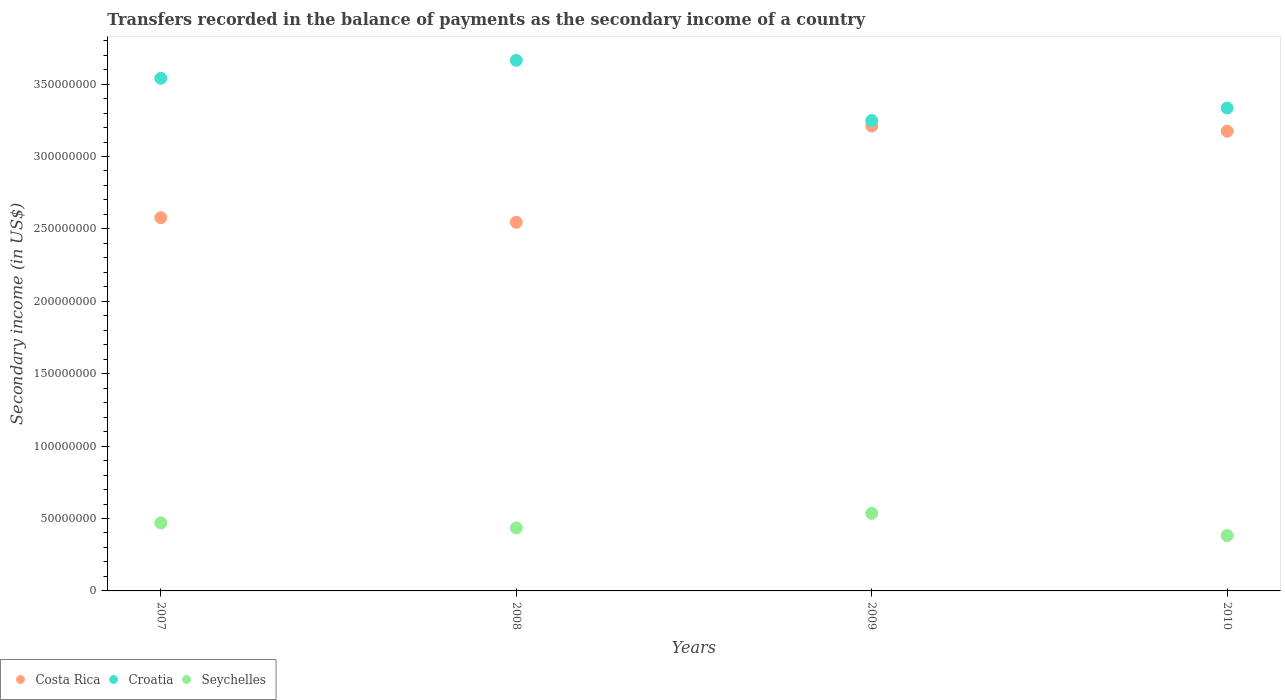Is the number of dotlines equal to the number of legend labels?
Give a very brief answer. Yes. What is the secondary income of in Croatia in 2007?
Your answer should be very brief. 3.54e+08. Across all years, what is the maximum secondary income of in Croatia?
Keep it short and to the point. 3.66e+08. Across all years, what is the minimum secondary income of in Croatia?
Your answer should be very brief. 3.25e+08. What is the total secondary income of in Croatia in the graph?
Keep it short and to the point. 1.38e+09. What is the difference between the secondary income of in Costa Rica in 2007 and that in 2009?
Keep it short and to the point. -6.33e+07. What is the difference between the secondary income of in Costa Rica in 2010 and the secondary income of in Seychelles in 2007?
Offer a very short reply. 2.71e+08. What is the average secondary income of in Seychelles per year?
Give a very brief answer. 4.55e+07. In the year 2008, what is the difference between the secondary income of in Costa Rica and secondary income of in Croatia?
Keep it short and to the point. -1.12e+08. In how many years, is the secondary income of in Seychelles greater than 10000000 US$?
Make the answer very short. 4. What is the ratio of the secondary income of in Costa Rica in 2007 to that in 2009?
Offer a very short reply. 0.8. What is the difference between the highest and the second highest secondary income of in Seychelles?
Provide a short and direct response. 6.59e+06. What is the difference between the highest and the lowest secondary income of in Croatia?
Give a very brief answer. 4.16e+07. In how many years, is the secondary income of in Seychelles greater than the average secondary income of in Seychelles taken over all years?
Provide a short and direct response. 2. Is it the case that in every year, the sum of the secondary income of in Seychelles and secondary income of in Croatia  is greater than the secondary income of in Costa Rica?
Provide a short and direct response. Yes. Is the secondary income of in Costa Rica strictly greater than the secondary income of in Croatia over the years?
Provide a succinct answer. No. How many dotlines are there?
Your answer should be compact. 3. How many years are there in the graph?
Make the answer very short. 4. What is the difference between two consecutive major ticks on the Y-axis?
Make the answer very short. 5.00e+07. Are the values on the major ticks of Y-axis written in scientific E-notation?
Offer a terse response. No. How many legend labels are there?
Your response must be concise. 3. What is the title of the graph?
Ensure brevity in your answer.  Transfers recorded in the balance of payments as the secondary income of a country. Does "Sri Lanka" appear as one of the legend labels in the graph?
Your answer should be compact. No. What is the label or title of the Y-axis?
Offer a terse response. Secondary income (in US$). What is the Secondary income (in US$) in Costa Rica in 2007?
Give a very brief answer. 2.58e+08. What is the Secondary income (in US$) in Croatia in 2007?
Offer a very short reply. 3.54e+08. What is the Secondary income (in US$) of Seychelles in 2007?
Your answer should be compact. 4.69e+07. What is the Secondary income (in US$) in Costa Rica in 2008?
Your answer should be very brief. 2.55e+08. What is the Secondary income (in US$) of Croatia in 2008?
Provide a short and direct response. 3.66e+08. What is the Secondary income (in US$) of Seychelles in 2008?
Provide a short and direct response. 4.35e+07. What is the Secondary income (in US$) in Costa Rica in 2009?
Make the answer very short. 3.21e+08. What is the Secondary income (in US$) in Croatia in 2009?
Provide a short and direct response. 3.25e+08. What is the Secondary income (in US$) of Seychelles in 2009?
Your answer should be compact. 5.35e+07. What is the Secondary income (in US$) of Costa Rica in 2010?
Your answer should be compact. 3.17e+08. What is the Secondary income (in US$) of Croatia in 2010?
Provide a succinct answer. 3.33e+08. What is the Secondary income (in US$) in Seychelles in 2010?
Your answer should be very brief. 3.82e+07. Across all years, what is the maximum Secondary income (in US$) of Costa Rica?
Keep it short and to the point. 3.21e+08. Across all years, what is the maximum Secondary income (in US$) of Croatia?
Give a very brief answer. 3.66e+08. Across all years, what is the maximum Secondary income (in US$) in Seychelles?
Give a very brief answer. 5.35e+07. Across all years, what is the minimum Secondary income (in US$) of Costa Rica?
Make the answer very short. 2.55e+08. Across all years, what is the minimum Secondary income (in US$) in Croatia?
Offer a terse response. 3.25e+08. Across all years, what is the minimum Secondary income (in US$) of Seychelles?
Make the answer very short. 3.82e+07. What is the total Secondary income (in US$) in Costa Rica in the graph?
Your answer should be compact. 1.15e+09. What is the total Secondary income (in US$) of Croatia in the graph?
Provide a short and direct response. 1.38e+09. What is the total Secondary income (in US$) of Seychelles in the graph?
Offer a terse response. 1.82e+08. What is the difference between the Secondary income (in US$) in Costa Rica in 2007 and that in 2008?
Give a very brief answer. 3.20e+06. What is the difference between the Secondary income (in US$) in Croatia in 2007 and that in 2008?
Provide a short and direct response. -1.24e+07. What is the difference between the Secondary income (in US$) of Seychelles in 2007 and that in 2008?
Offer a terse response. 3.44e+06. What is the difference between the Secondary income (in US$) of Costa Rica in 2007 and that in 2009?
Ensure brevity in your answer.  -6.33e+07. What is the difference between the Secondary income (in US$) of Croatia in 2007 and that in 2009?
Offer a terse response. 2.92e+07. What is the difference between the Secondary income (in US$) in Seychelles in 2007 and that in 2009?
Offer a terse response. -6.59e+06. What is the difference between the Secondary income (in US$) in Costa Rica in 2007 and that in 2010?
Give a very brief answer. -5.97e+07. What is the difference between the Secondary income (in US$) of Croatia in 2007 and that in 2010?
Keep it short and to the point. 2.05e+07. What is the difference between the Secondary income (in US$) in Seychelles in 2007 and that in 2010?
Ensure brevity in your answer.  8.74e+06. What is the difference between the Secondary income (in US$) of Costa Rica in 2008 and that in 2009?
Offer a very short reply. -6.65e+07. What is the difference between the Secondary income (in US$) of Croatia in 2008 and that in 2009?
Your answer should be very brief. 4.16e+07. What is the difference between the Secondary income (in US$) of Seychelles in 2008 and that in 2009?
Offer a very short reply. -1.00e+07. What is the difference between the Secondary income (in US$) of Costa Rica in 2008 and that in 2010?
Provide a succinct answer. -6.29e+07. What is the difference between the Secondary income (in US$) in Croatia in 2008 and that in 2010?
Your response must be concise. 3.29e+07. What is the difference between the Secondary income (in US$) of Seychelles in 2008 and that in 2010?
Your answer should be compact. 5.30e+06. What is the difference between the Secondary income (in US$) of Costa Rica in 2009 and that in 2010?
Offer a very short reply. 3.59e+06. What is the difference between the Secondary income (in US$) in Croatia in 2009 and that in 2010?
Offer a very short reply. -8.65e+06. What is the difference between the Secondary income (in US$) of Seychelles in 2009 and that in 2010?
Keep it short and to the point. 1.53e+07. What is the difference between the Secondary income (in US$) of Costa Rica in 2007 and the Secondary income (in US$) of Croatia in 2008?
Give a very brief answer. -1.09e+08. What is the difference between the Secondary income (in US$) in Costa Rica in 2007 and the Secondary income (in US$) in Seychelles in 2008?
Make the answer very short. 2.14e+08. What is the difference between the Secondary income (in US$) of Croatia in 2007 and the Secondary income (in US$) of Seychelles in 2008?
Offer a very short reply. 3.11e+08. What is the difference between the Secondary income (in US$) of Costa Rica in 2007 and the Secondary income (in US$) of Croatia in 2009?
Offer a very short reply. -6.71e+07. What is the difference between the Secondary income (in US$) of Costa Rica in 2007 and the Secondary income (in US$) of Seychelles in 2009?
Offer a terse response. 2.04e+08. What is the difference between the Secondary income (in US$) of Croatia in 2007 and the Secondary income (in US$) of Seychelles in 2009?
Give a very brief answer. 3.00e+08. What is the difference between the Secondary income (in US$) in Costa Rica in 2007 and the Secondary income (in US$) in Croatia in 2010?
Offer a terse response. -7.57e+07. What is the difference between the Secondary income (in US$) in Costa Rica in 2007 and the Secondary income (in US$) in Seychelles in 2010?
Make the answer very short. 2.20e+08. What is the difference between the Secondary income (in US$) of Croatia in 2007 and the Secondary income (in US$) of Seychelles in 2010?
Offer a very short reply. 3.16e+08. What is the difference between the Secondary income (in US$) of Costa Rica in 2008 and the Secondary income (in US$) of Croatia in 2009?
Provide a succinct answer. -7.03e+07. What is the difference between the Secondary income (in US$) in Costa Rica in 2008 and the Secondary income (in US$) in Seychelles in 2009?
Offer a terse response. 2.01e+08. What is the difference between the Secondary income (in US$) of Croatia in 2008 and the Secondary income (in US$) of Seychelles in 2009?
Your response must be concise. 3.13e+08. What is the difference between the Secondary income (in US$) in Costa Rica in 2008 and the Secondary income (in US$) in Croatia in 2010?
Keep it short and to the point. -7.89e+07. What is the difference between the Secondary income (in US$) in Costa Rica in 2008 and the Secondary income (in US$) in Seychelles in 2010?
Give a very brief answer. 2.16e+08. What is the difference between the Secondary income (in US$) of Croatia in 2008 and the Secondary income (in US$) of Seychelles in 2010?
Provide a short and direct response. 3.28e+08. What is the difference between the Secondary income (in US$) in Costa Rica in 2009 and the Secondary income (in US$) in Croatia in 2010?
Provide a short and direct response. -1.24e+07. What is the difference between the Secondary income (in US$) in Costa Rica in 2009 and the Secondary income (in US$) in Seychelles in 2010?
Offer a terse response. 2.83e+08. What is the difference between the Secondary income (in US$) in Croatia in 2009 and the Secondary income (in US$) in Seychelles in 2010?
Give a very brief answer. 2.87e+08. What is the average Secondary income (in US$) in Costa Rica per year?
Provide a short and direct response. 2.88e+08. What is the average Secondary income (in US$) in Croatia per year?
Your response must be concise. 3.45e+08. What is the average Secondary income (in US$) in Seychelles per year?
Keep it short and to the point. 4.55e+07. In the year 2007, what is the difference between the Secondary income (in US$) in Costa Rica and Secondary income (in US$) in Croatia?
Provide a succinct answer. -9.62e+07. In the year 2007, what is the difference between the Secondary income (in US$) of Costa Rica and Secondary income (in US$) of Seychelles?
Ensure brevity in your answer.  2.11e+08. In the year 2007, what is the difference between the Secondary income (in US$) of Croatia and Secondary income (in US$) of Seychelles?
Your answer should be very brief. 3.07e+08. In the year 2008, what is the difference between the Secondary income (in US$) in Costa Rica and Secondary income (in US$) in Croatia?
Offer a terse response. -1.12e+08. In the year 2008, what is the difference between the Secondary income (in US$) of Costa Rica and Secondary income (in US$) of Seychelles?
Offer a terse response. 2.11e+08. In the year 2008, what is the difference between the Secondary income (in US$) in Croatia and Secondary income (in US$) in Seychelles?
Give a very brief answer. 3.23e+08. In the year 2009, what is the difference between the Secondary income (in US$) in Costa Rica and Secondary income (in US$) in Croatia?
Offer a very short reply. -3.76e+06. In the year 2009, what is the difference between the Secondary income (in US$) of Costa Rica and Secondary income (in US$) of Seychelles?
Provide a succinct answer. 2.68e+08. In the year 2009, what is the difference between the Secondary income (in US$) in Croatia and Secondary income (in US$) in Seychelles?
Your answer should be very brief. 2.71e+08. In the year 2010, what is the difference between the Secondary income (in US$) in Costa Rica and Secondary income (in US$) in Croatia?
Make the answer very short. -1.60e+07. In the year 2010, what is the difference between the Secondary income (in US$) of Costa Rica and Secondary income (in US$) of Seychelles?
Your answer should be compact. 2.79e+08. In the year 2010, what is the difference between the Secondary income (in US$) of Croatia and Secondary income (in US$) of Seychelles?
Your answer should be compact. 2.95e+08. What is the ratio of the Secondary income (in US$) of Costa Rica in 2007 to that in 2008?
Provide a short and direct response. 1.01. What is the ratio of the Secondary income (in US$) of Croatia in 2007 to that in 2008?
Make the answer very short. 0.97. What is the ratio of the Secondary income (in US$) in Seychelles in 2007 to that in 2008?
Provide a succinct answer. 1.08. What is the ratio of the Secondary income (in US$) in Costa Rica in 2007 to that in 2009?
Ensure brevity in your answer.  0.8. What is the ratio of the Secondary income (in US$) of Croatia in 2007 to that in 2009?
Keep it short and to the point. 1.09. What is the ratio of the Secondary income (in US$) in Seychelles in 2007 to that in 2009?
Keep it short and to the point. 0.88. What is the ratio of the Secondary income (in US$) in Costa Rica in 2007 to that in 2010?
Your response must be concise. 0.81. What is the ratio of the Secondary income (in US$) in Croatia in 2007 to that in 2010?
Provide a succinct answer. 1.06. What is the ratio of the Secondary income (in US$) of Seychelles in 2007 to that in 2010?
Give a very brief answer. 1.23. What is the ratio of the Secondary income (in US$) of Costa Rica in 2008 to that in 2009?
Provide a succinct answer. 0.79. What is the ratio of the Secondary income (in US$) in Croatia in 2008 to that in 2009?
Make the answer very short. 1.13. What is the ratio of the Secondary income (in US$) of Seychelles in 2008 to that in 2009?
Offer a very short reply. 0.81. What is the ratio of the Secondary income (in US$) in Costa Rica in 2008 to that in 2010?
Provide a succinct answer. 0.8. What is the ratio of the Secondary income (in US$) in Croatia in 2008 to that in 2010?
Give a very brief answer. 1.1. What is the ratio of the Secondary income (in US$) of Seychelles in 2008 to that in 2010?
Your answer should be compact. 1.14. What is the ratio of the Secondary income (in US$) of Costa Rica in 2009 to that in 2010?
Your answer should be compact. 1.01. What is the ratio of the Secondary income (in US$) of Croatia in 2009 to that in 2010?
Offer a very short reply. 0.97. What is the ratio of the Secondary income (in US$) of Seychelles in 2009 to that in 2010?
Your response must be concise. 1.4. What is the difference between the highest and the second highest Secondary income (in US$) in Costa Rica?
Offer a very short reply. 3.59e+06. What is the difference between the highest and the second highest Secondary income (in US$) of Croatia?
Offer a very short reply. 1.24e+07. What is the difference between the highest and the second highest Secondary income (in US$) in Seychelles?
Your answer should be very brief. 6.59e+06. What is the difference between the highest and the lowest Secondary income (in US$) of Costa Rica?
Offer a very short reply. 6.65e+07. What is the difference between the highest and the lowest Secondary income (in US$) of Croatia?
Ensure brevity in your answer.  4.16e+07. What is the difference between the highest and the lowest Secondary income (in US$) of Seychelles?
Your response must be concise. 1.53e+07. 